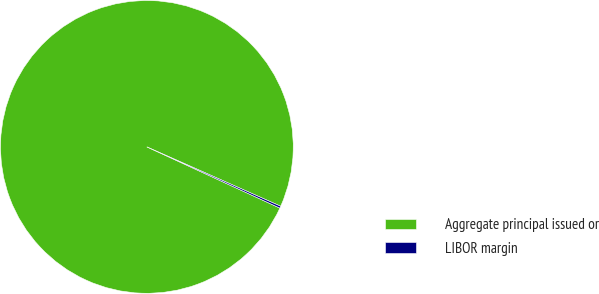<chart> <loc_0><loc_0><loc_500><loc_500><pie_chart><fcel>Aggregate principal issued or<fcel>LIBOR margin<nl><fcel>99.78%<fcel>0.22%<nl></chart> 